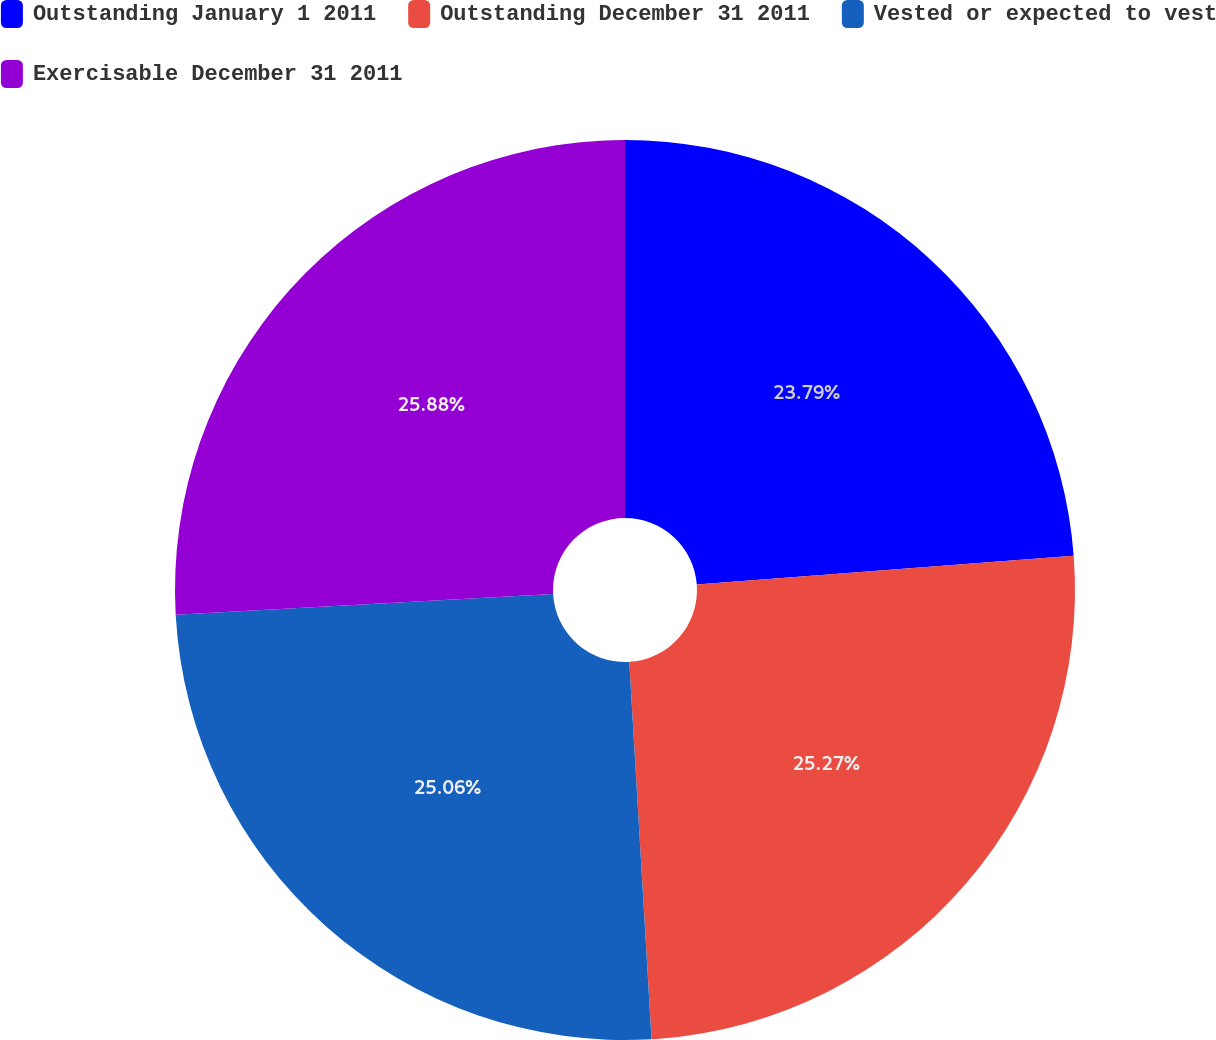Convert chart. <chart><loc_0><loc_0><loc_500><loc_500><pie_chart><fcel>Outstanding January 1 2011<fcel>Outstanding December 31 2011<fcel>Vested or expected to vest<fcel>Exercisable December 31 2011<nl><fcel>23.79%<fcel>25.27%<fcel>25.06%<fcel>25.88%<nl></chart> 